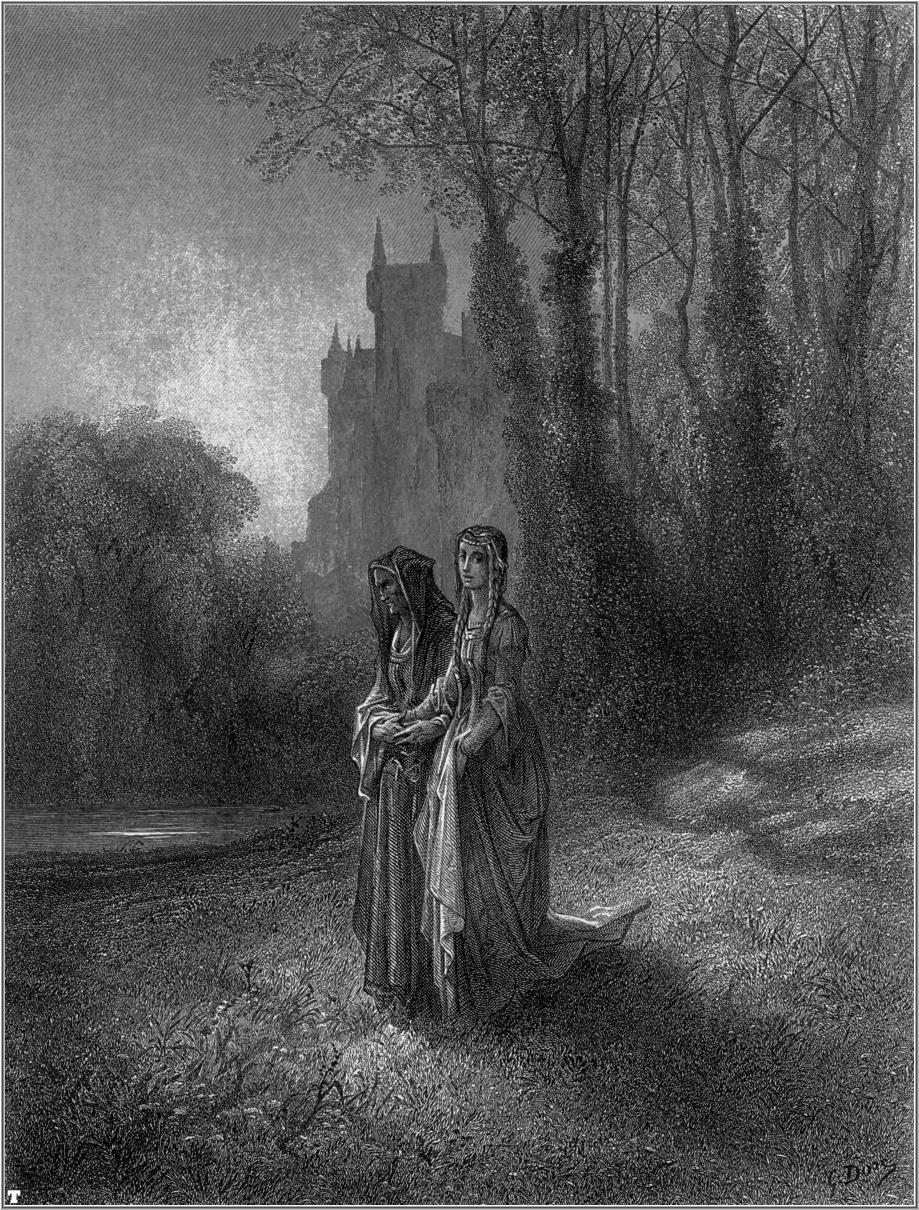Write a detailed description of the given image. This is a striking black-and-white illustration that captures a serene and somewhat mystical moment in a forest setting. In the foreground, two women are depicted walking through the lush forest floor, adorned in long, flowing dresses that exude an air of elegance and grace. One of the women holds a basket, possibly containing foraged items or flowers, adding a sense of daily life's simplicity and charm. The artwork is rendered in a realist style, with painstaking attention to the textures of the women's garments and the intricate foliage surrounding them. A castle, showcased in the background, looms majestically above the trees, shrouded in a misty ambiance that amplifies the romantic and nostalgic mood of the scene. The vertical composition of the image serves to accentuate the soaring trees and the imposing silhouette of the castle, thus drawing the viewer's eye upwards. Despite being colorless, the illustration is rich in depth and intricate details, creating a captivating visual story replete with texture and quiet beauty. 